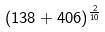<formula> <loc_0><loc_0><loc_500><loc_500>( 1 3 8 + 4 0 6 ) ^ { \frac { 2 } { 1 0 } }</formula> 